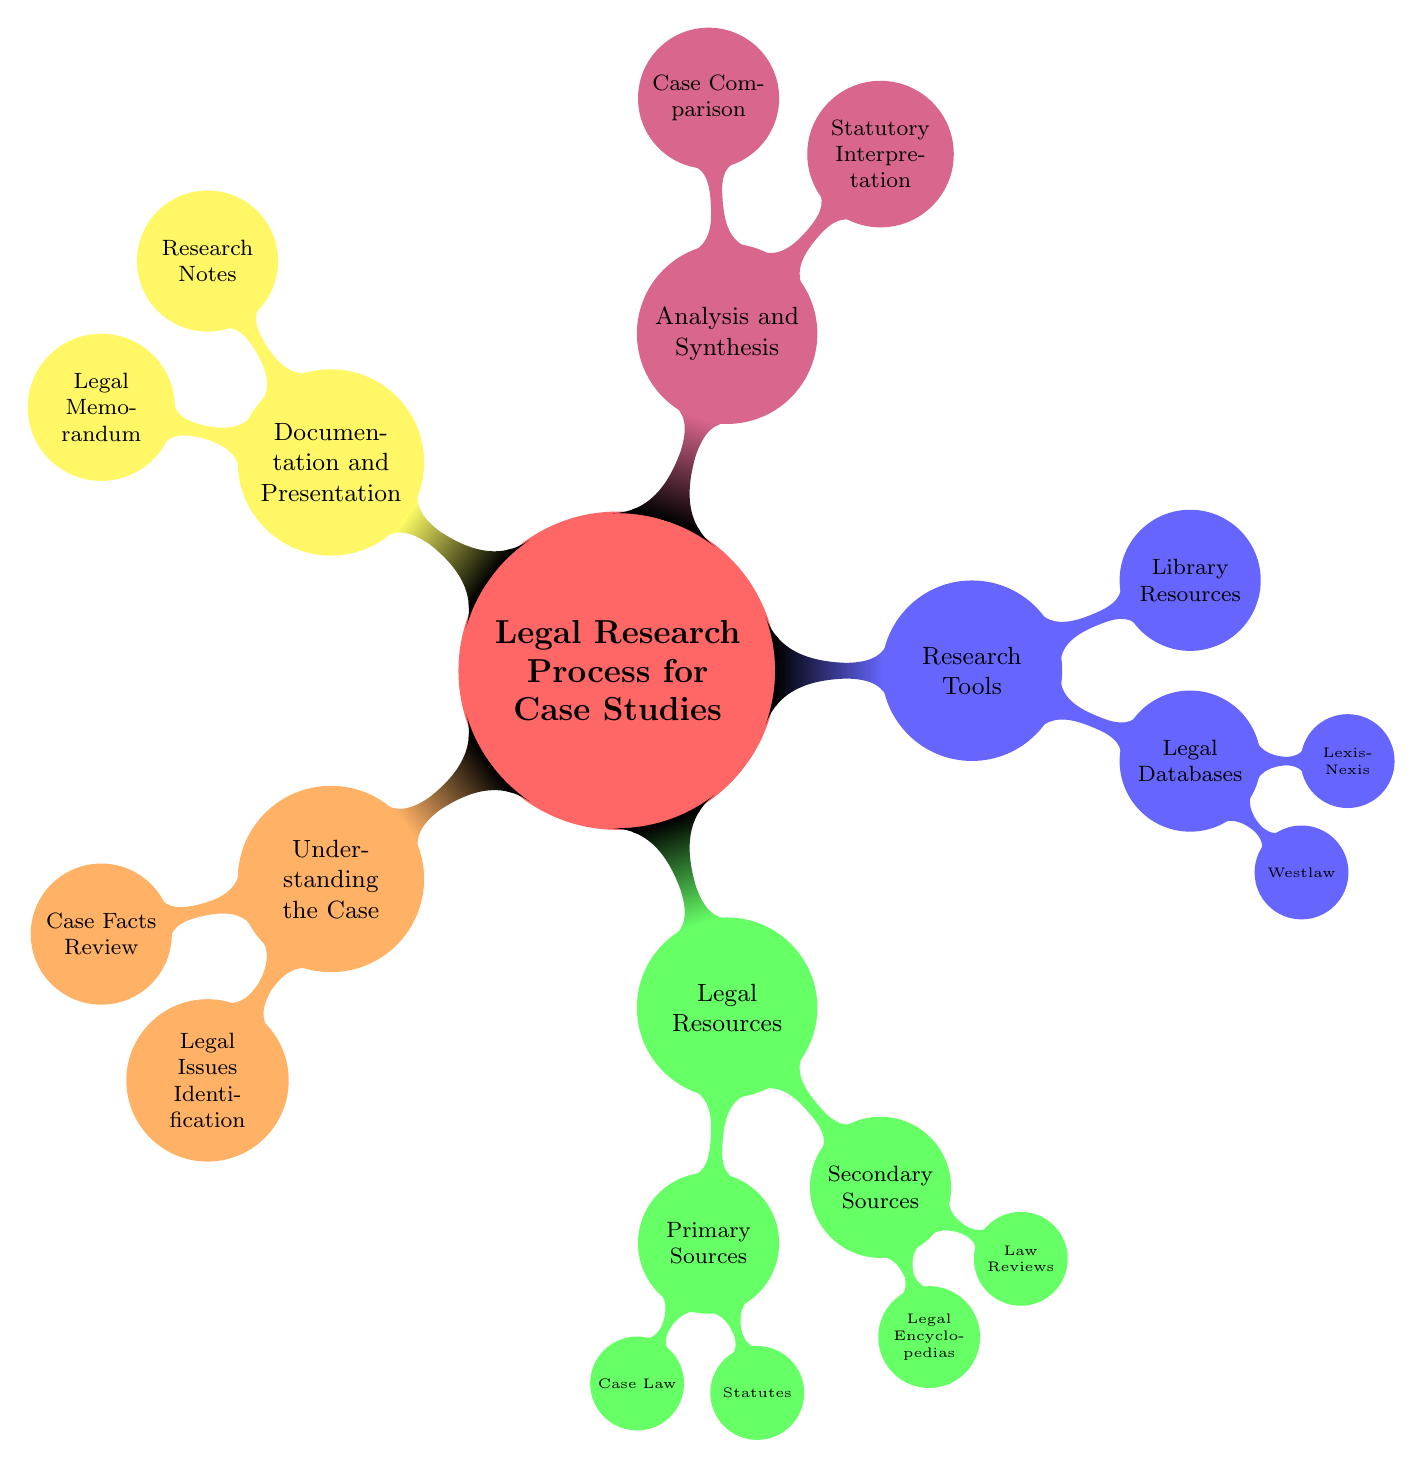What is the main topic of this mind map? The main topic is located at the center node of the diagram, which is titled "Legal Research Process for Case Studies."
Answer: Legal Research Process for Case Studies How many primary source nodes are there? In the "Legal Resources" section, there are two primary source nodes: "Case Law" and "Statutes." Thus, the total is counted.
Answer: 2 What are the two types of legal resources mentioned? By observing the "Legal Resources" section, it can be seen that there are two main types: "Primary Sources" and "Secondary Sources."
Answer: Primary Sources, Secondary Sources What node falls under "Research Tools" that is related to legal databases? Looking under the "Research Tools" section, two child nodes are present: "Westlaw" and "LexisNexis," both of which are related to legal databases.
Answer: Westlaw, LexisNexis Which section includes "Research Notes"? "Research Notes" is found in the "Documentation and Presentation" section, which encompasses nodes focused on documenting the legal research process.
Answer: Documentation and Presentation What does "Case Comparison" involve? The node "Case Comparison" falls under the "Analysis and Synthesis" section, indicating it is about analyzing and comparing different legal cases to enhance understanding of a case's context.
Answer: Comparing similar case precedents How many nodes are in the "Understanding the Case" section? The "Understanding the Case" section contains two child nodes: "Case Facts Review" and "Legal Issues Identification," leading to a total of two nodes present in that section.
Answer: 2 What is one use of "Legal Memorandum"? The "Legal Memorandum" node, which is included under "Documentation and Presentation," primarily serves to summarize research findings in a structured format.
Answer: Summarizing research What type of resources can be found in "Library Resources"? The node "Library Resources" appears under "Research Tools," suggesting that it refers to physical or digital resources available in a law library, likely for research purposes.
Answer: University law library resources 